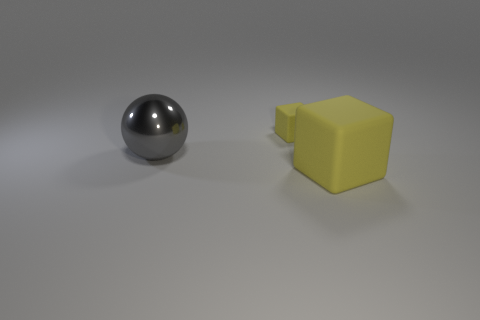How many yellow cubes must be subtracted to get 1 yellow cubes? 1 Add 3 gray cubes. How many objects exist? 6 Add 2 large gray metallic balls. How many large gray metallic balls are left? 3 Add 3 small cubes. How many small cubes exist? 4 Subtract 0 green balls. How many objects are left? 3 Subtract all spheres. How many objects are left? 2 Subtract 1 blocks. How many blocks are left? 1 Subtract all cyan blocks. Subtract all purple cylinders. How many blocks are left? 2 Subtract all cyan cubes. How many brown balls are left? 0 Subtract all yellow objects. Subtract all large brown cylinders. How many objects are left? 1 